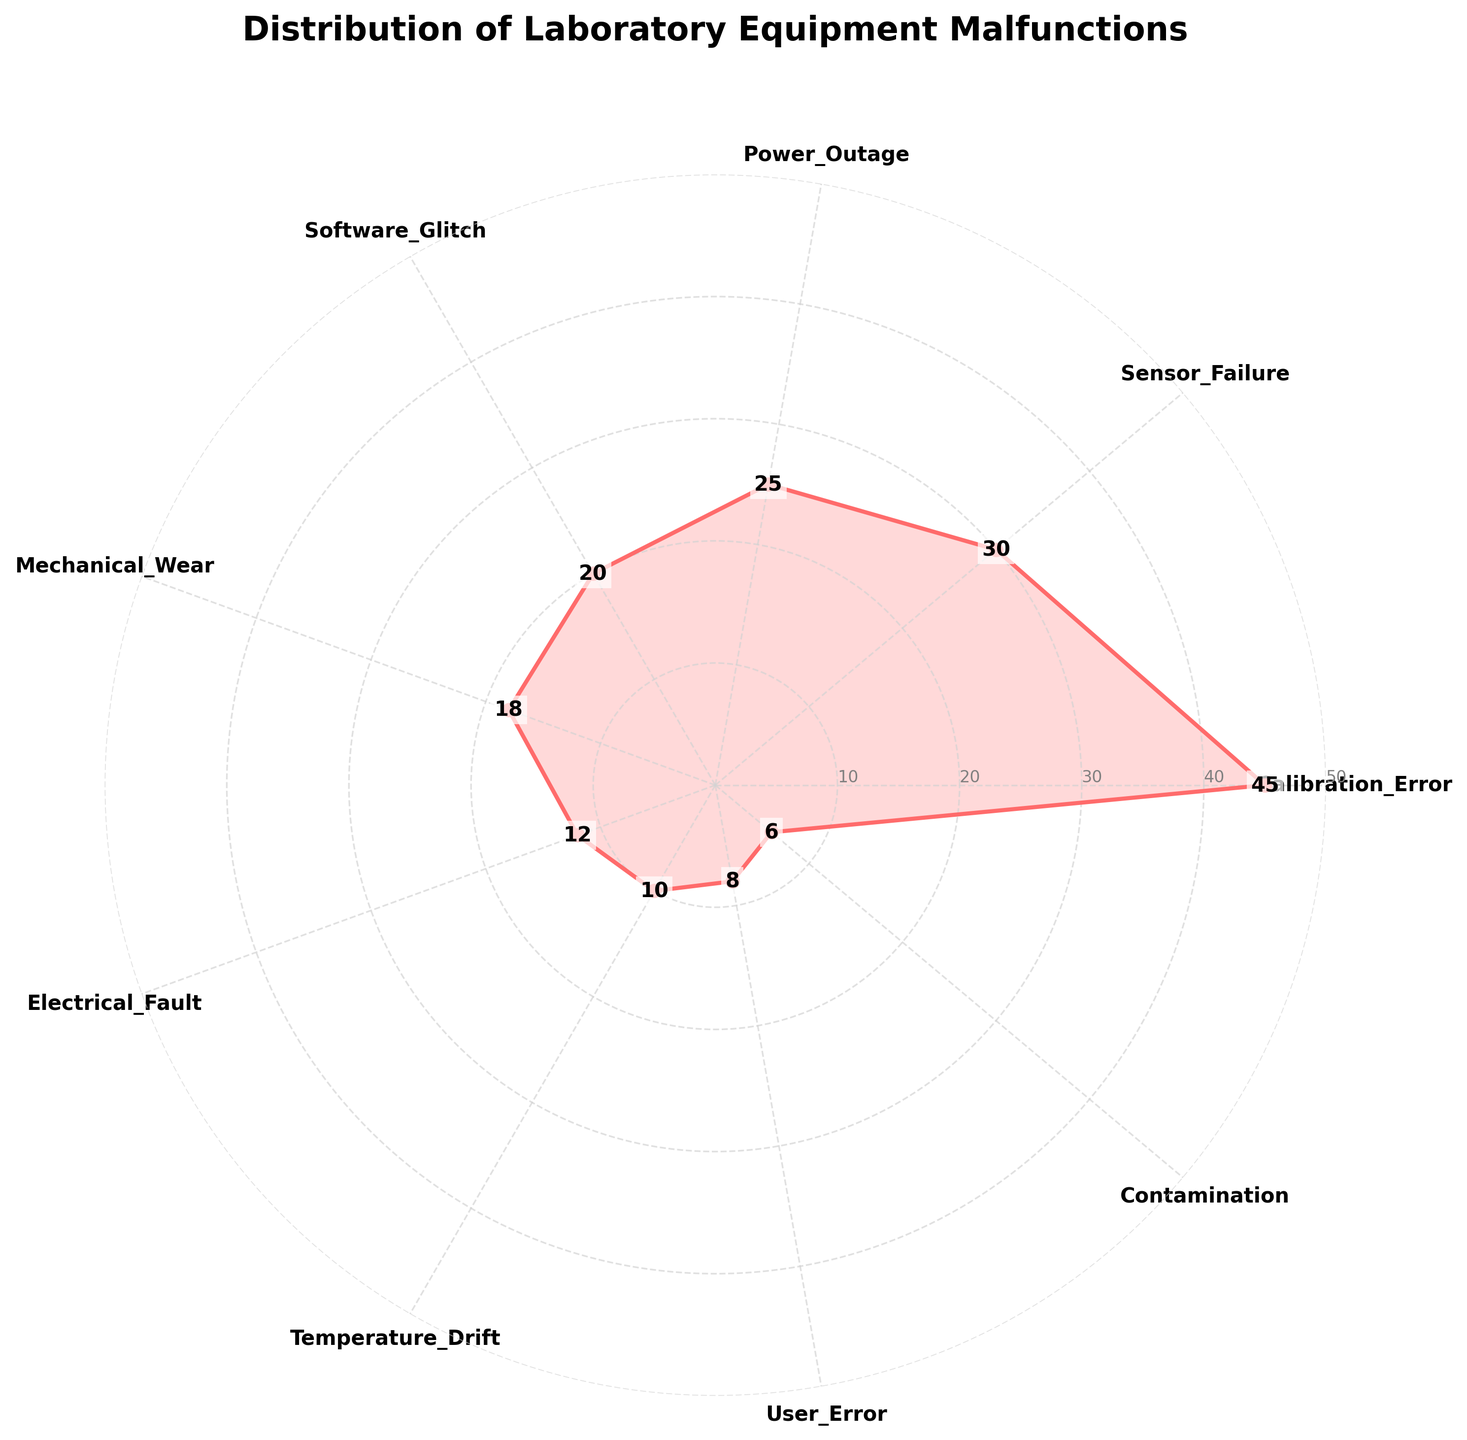What is the title of the rose chart? The title is located at the top of the figure and summarizes what the chart represents. It reads "Distribution of Laboratory Equipment Malfunctions".
Answer: Distribution of Laboratory Equipment Malfunctions How many types of malfunctions are depicted in the chart? The chart has labels for each type of malfunction at the tick marks around the polar plot. Counting these labels provides the number.
Answer: 9 Which malfunction type has the highest count? By looking at the farthest extending segment from the chart's center, labeled accordingly, we determine the malfunction with the most incidents.
Answer: Calibration_Error What is the second most common malfunction? The position of the second-longest segment indicates the second highest count. Using label annotations, determine the corresponding malfunction type.
Answer: Sensor_Failure What is the total count of all listed malfunctions? Adding up the count values from each segment in the chart provides the total number of malfunctions. The counts are 45, 30, 25, 20, 18, 12, 10, 8, 6. Summing these gives 174.
Answer: 174 What is the average count of malfunctions per type? Calculating the total count and dividing it by the number of malfunction types gives the average. Total count is 174, divided by 9 types.
Answer: 19.33 How does the count of Sensor Failure compare to Power Outage? Subtract the counts to find the difference. Sensor Failure has 30 and Power Outage has 25. The difference is 5.
Answer: 5 Which malfunction type has the smallest count and what is the value? Identify the shortest segment in the rose chart and check the label for the corresponding malfunction type.
Answer: Contamination, 6 Are there more malfunctions due to Software Glitch or Mechanical Wear? Comparing the lengths of segments for Software Glitch (20) and Mechanical Wear (18) shows that Software Glitch has more malfunctions.
Answer: Software Glitch What proportion of the total malfunctions does Calibration Error represent? Divide the count of Calibration Error (45) by the total count (174) and multiply by 100 to get the percentage. \( \frac{45}{174} \approx 25.86 \% \)
Answer: 25.86% 